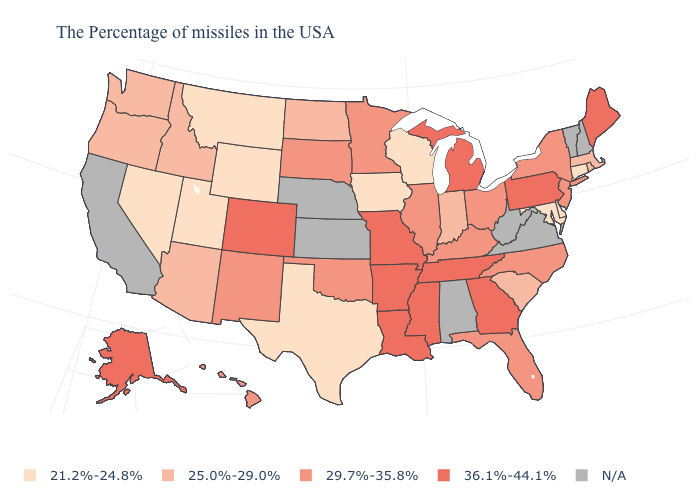Which states have the highest value in the USA?
Quick response, please. Maine, Pennsylvania, Georgia, Michigan, Tennessee, Mississippi, Louisiana, Missouri, Arkansas, Colorado, Alaska. What is the value of Arizona?
Answer briefly. 25.0%-29.0%. Does the first symbol in the legend represent the smallest category?
Quick response, please. Yes. How many symbols are there in the legend?
Be succinct. 5. What is the value of South Carolina?
Quick response, please. 25.0%-29.0%. How many symbols are there in the legend?
Answer briefly. 5. Name the states that have a value in the range 29.7%-35.8%?
Answer briefly. New York, New Jersey, North Carolina, Ohio, Florida, Kentucky, Illinois, Minnesota, Oklahoma, South Dakota, New Mexico, Hawaii. What is the value of Georgia?
Give a very brief answer. 36.1%-44.1%. What is the value of Kentucky?
Be succinct. 29.7%-35.8%. What is the highest value in the USA?
Answer briefly. 36.1%-44.1%. Among the states that border Arizona , which have the lowest value?
Give a very brief answer. Utah, Nevada. Which states have the lowest value in the USA?
Write a very short answer. Connecticut, Delaware, Maryland, Wisconsin, Iowa, Texas, Wyoming, Utah, Montana, Nevada. What is the value of Utah?
Answer briefly. 21.2%-24.8%. Does Nevada have the lowest value in the USA?
Be succinct. Yes. Among the states that border Delaware , which have the highest value?
Be succinct. Pennsylvania. 